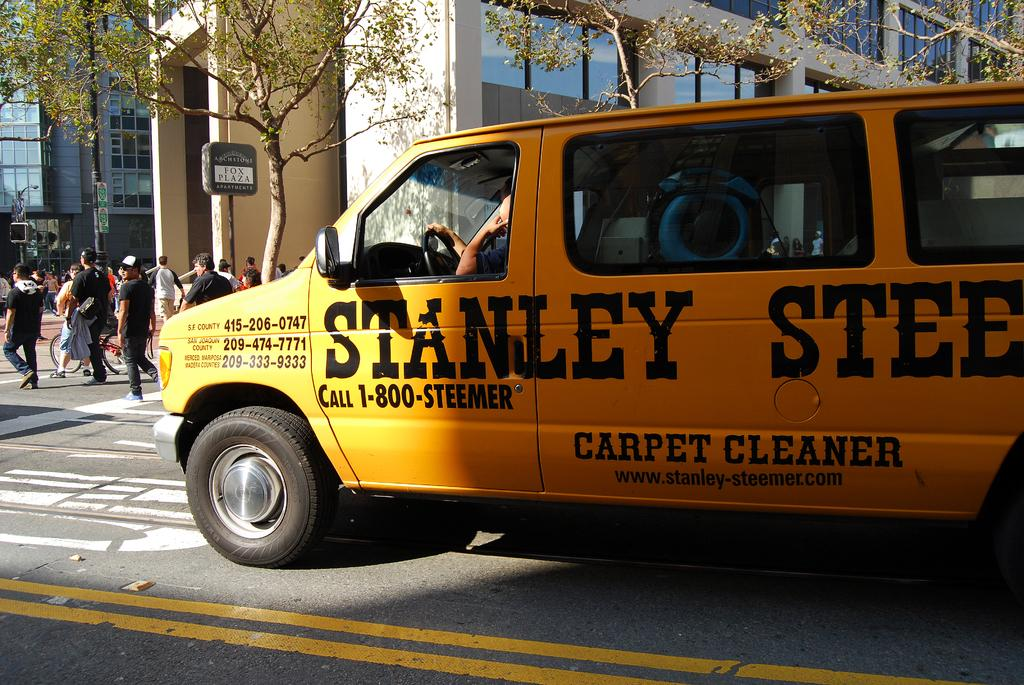What is the main subject in the foreground of the image? There is a van in the foreground of the picture. What are the people in the image doing? The people walking down the road on the left side of the image are walking. What can be seen in the background of the image? There are trees, buildings, a pole, and a board in the background of the image. What type of base can be seen supporting the letter in the image? There is no base or letter present in the image. How is the distribution of the items in the image? The distribution of the items in the image cannot be determined without more specific information about the arrangement of the objects. 